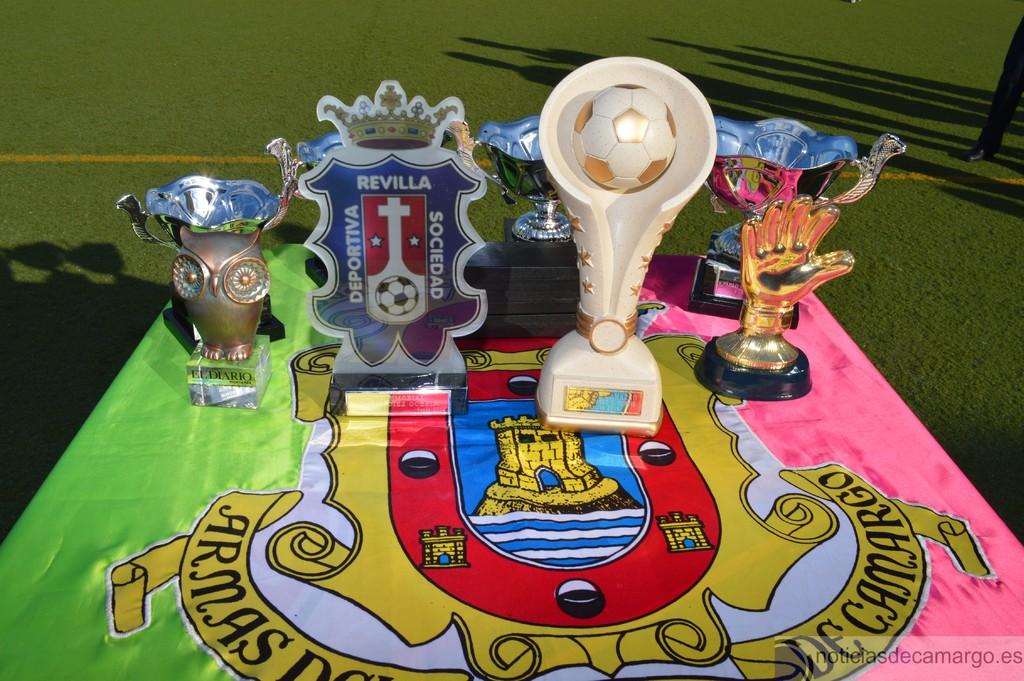What are the words around the soccer ball under the cross?
Ensure brevity in your answer.  Deportiva revilla sociedad. What is the first word on the coat of arms on the table?
Keep it short and to the point. Armas. 